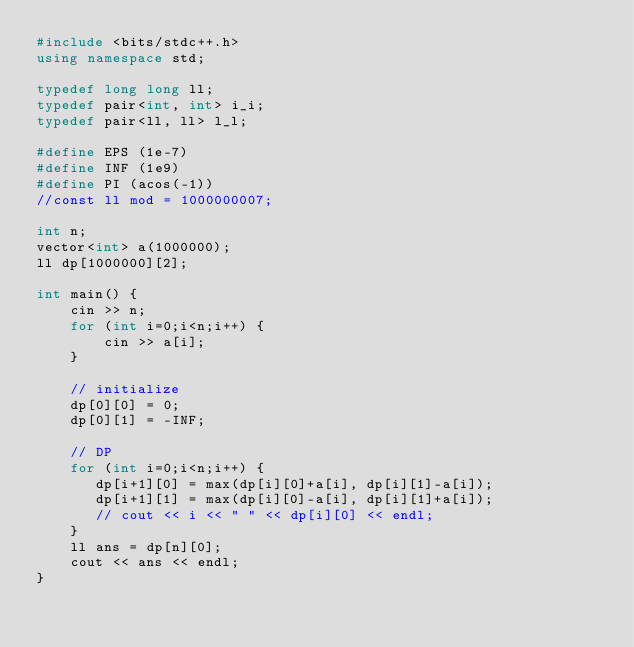Convert code to text. <code><loc_0><loc_0><loc_500><loc_500><_C++_>#include <bits/stdc++.h>
using namespace std;

typedef long long ll;
typedef pair<int, int> i_i;
typedef pair<ll, ll> l_l;
 
#define EPS (1e-7)
#define INF (1e9)
#define PI (acos(-1))
//const ll mod = 1000000007;

int n;
vector<int> a(1000000);
ll dp[1000000][2];

int main() {
    cin >> n;
    for (int i=0;i<n;i++) {
        cin >> a[i];
    }

    // initialize
    dp[0][0] = 0;
    dp[0][1] = -INF;

    // DP
    for (int i=0;i<n;i++) {
       dp[i+1][0] = max(dp[i][0]+a[i], dp[i][1]-a[i]);
       dp[i+1][1] = max(dp[i][0]-a[i], dp[i][1]+a[i]);
       // cout << i << " " << dp[i][0] << endl;
    }
    ll ans = dp[n][0];
    cout << ans << endl;
}</code> 